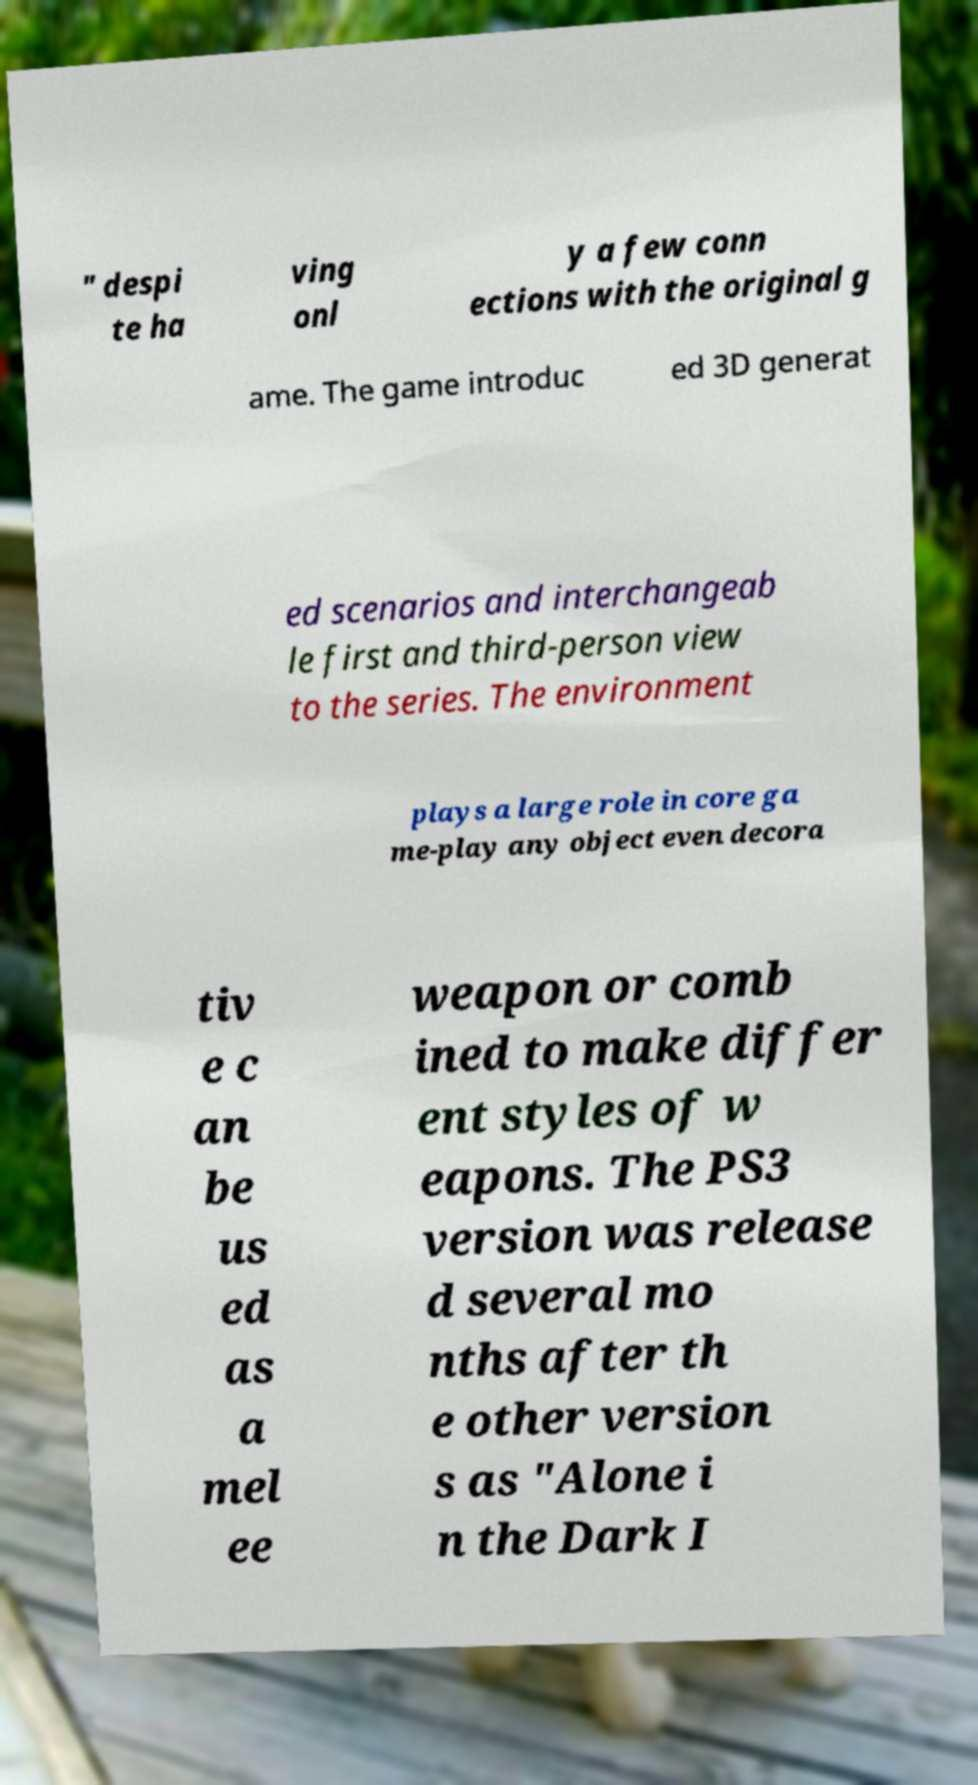For documentation purposes, I need the text within this image transcribed. Could you provide that? " despi te ha ving onl y a few conn ections with the original g ame. The game introduc ed 3D generat ed scenarios and interchangeab le first and third-person view to the series. The environment plays a large role in core ga me-play any object even decora tiv e c an be us ed as a mel ee weapon or comb ined to make differ ent styles of w eapons. The PS3 version was release d several mo nths after th e other version s as "Alone i n the Dark I 